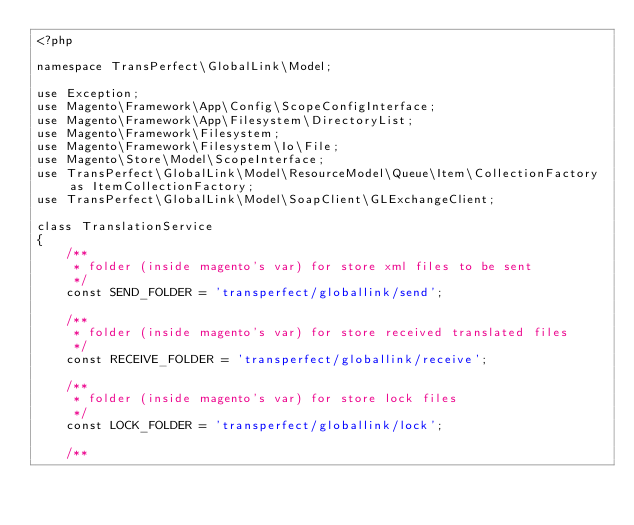<code> <loc_0><loc_0><loc_500><loc_500><_PHP_><?php

namespace TransPerfect\GlobalLink\Model;

use Exception;
use Magento\Framework\App\Config\ScopeConfigInterface;
use Magento\Framework\App\Filesystem\DirectoryList;
use Magento\Framework\Filesystem;
use Magento\Framework\Filesystem\Io\File;
use Magento\Store\Model\ScopeInterface;
use TransPerfect\GlobalLink\Model\ResourceModel\Queue\Item\CollectionFactory as ItemCollectionFactory;
use TransPerfect\GlobalLink\Model\SoapClient\GLExchangeClient;

class TranslationService
{
    /**
     * folder (inside magento's var) for store xml files to be sent
     */
    const SEND_FOLDER = 'transperfect/globallink/send';

    /**
     * folder (inside magento's var) for store received translated files
     */
    const RECEIVE_FOLDER = 'transperfect/globallink/receive';

    /**
     * folder (inside magento's var) for store lock files
     */
    const LOCK_FOLDER = 'transperfect/globallink/lock';

    /**</code> 